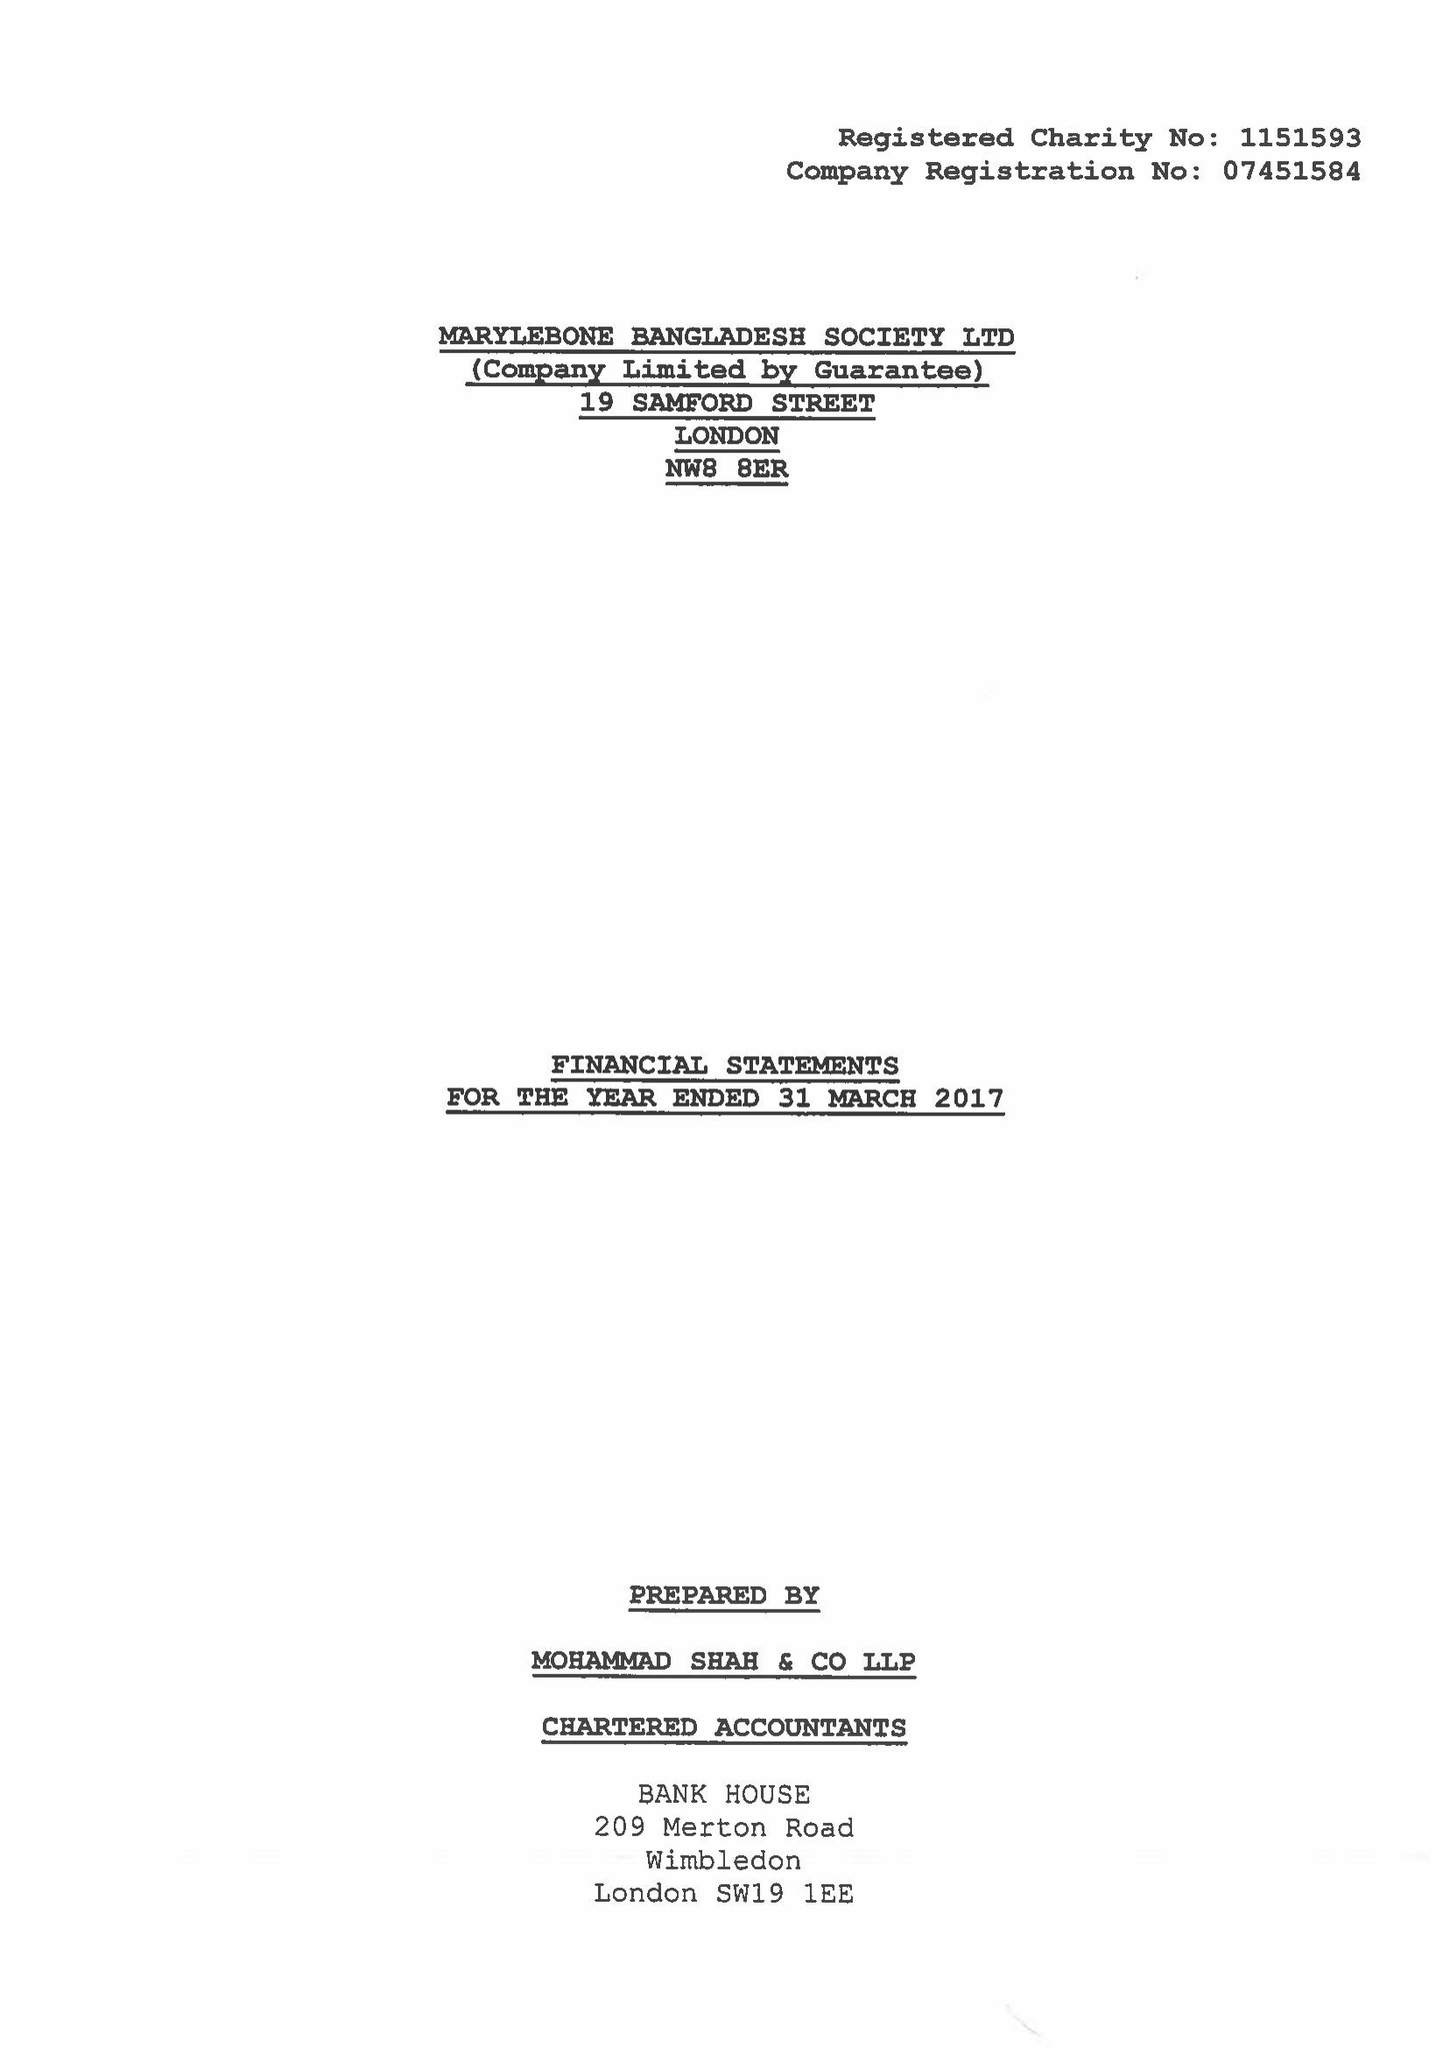What is the value for the charity_name?
Answer the question using a single word or phrase. Marylebone Bangladesh Society Ltd. 